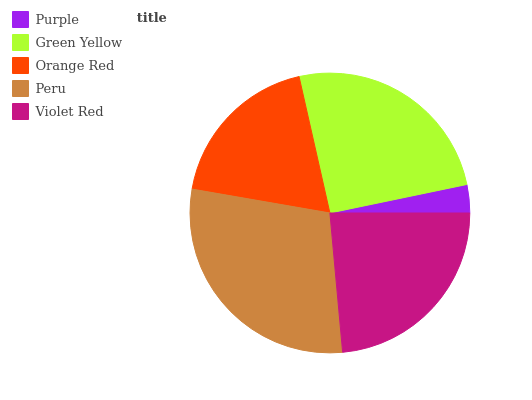Is Purple the minimum?
Answer yes or no. Yes. Is Peru the maximum?
Answer yes or no. Yes. Is Green Yellow the minimum?
Answer yes or no. No. Is Green Yellow the maximum?
Answer yes or no. No. Is Green Yellow greater than Purple?
Answer yes or no. Yes. Is Purple less than Green Yellow?
Answer yes or no. Yes. Is Purple greater than Green Yellow?
Answer yes or no. No. Is Green Yellow less than Purple?
Answer yes or no. No. Is Violet Red the high median?
Answer yes or no. Yes. Is Violet Red the low median?
Answer yes or no. Yes. Is Purple the high median?
Answer yes or no. No. Is Purple the low median?
Answer yes or no. No. 